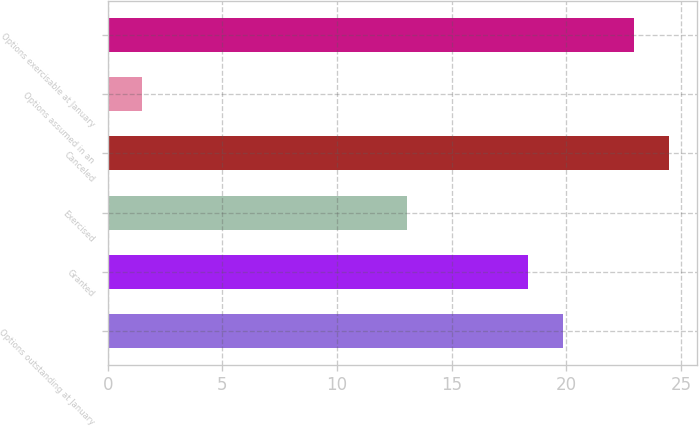Convert chart. <chart><loc_0><loc_0><loc_500><loc_500><bar_chart><fcel>Options outstanding at January<fcel>Granted<fcel>Exercised<fcel>Canceled<fcel>Options assumed in an<fcel>Options exercisable at January<nl><fcel>19.86<fcel>18.32<fcel>13.05<fcel>24.48<fcel>1.51<fcel>22.94<nl></chart> 